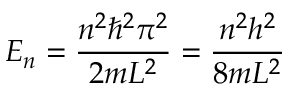Convert formula to latex. <formula><loc_0><loc_0><loc_500><loc_500>E _ { n } = { \frac { n ^ { 2 } \hbar { ^ } { 2 } \pi ^ { 2 } } { 2 m L ^ { 2 } } } = { \frac { n ^ { 2 } h ^ { 2 } } { 8 m L ^ { 2 } } }</formula> 